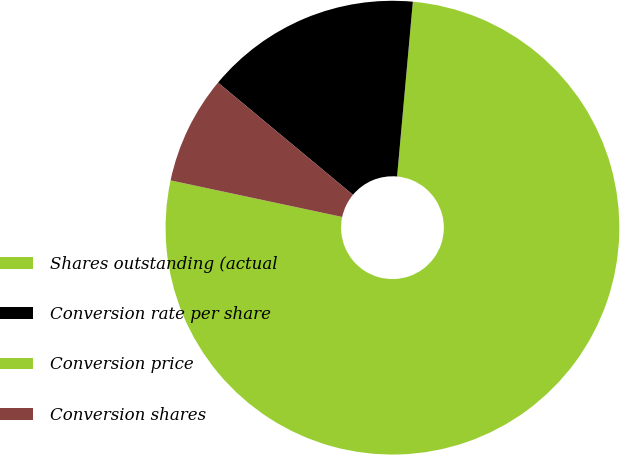Convert chart. <chart><loc_0><loc_0><loc_500><loc_500><pie_chart><fcel>Shares outstanding (actual<fcel>Conversion rate per share<fcel>Conversion price<fcel>Conversion shares<nl><fcel>76.91%<fcel>15.39%<fcel>0.0%<fcel>7.7%<nl></chart> 